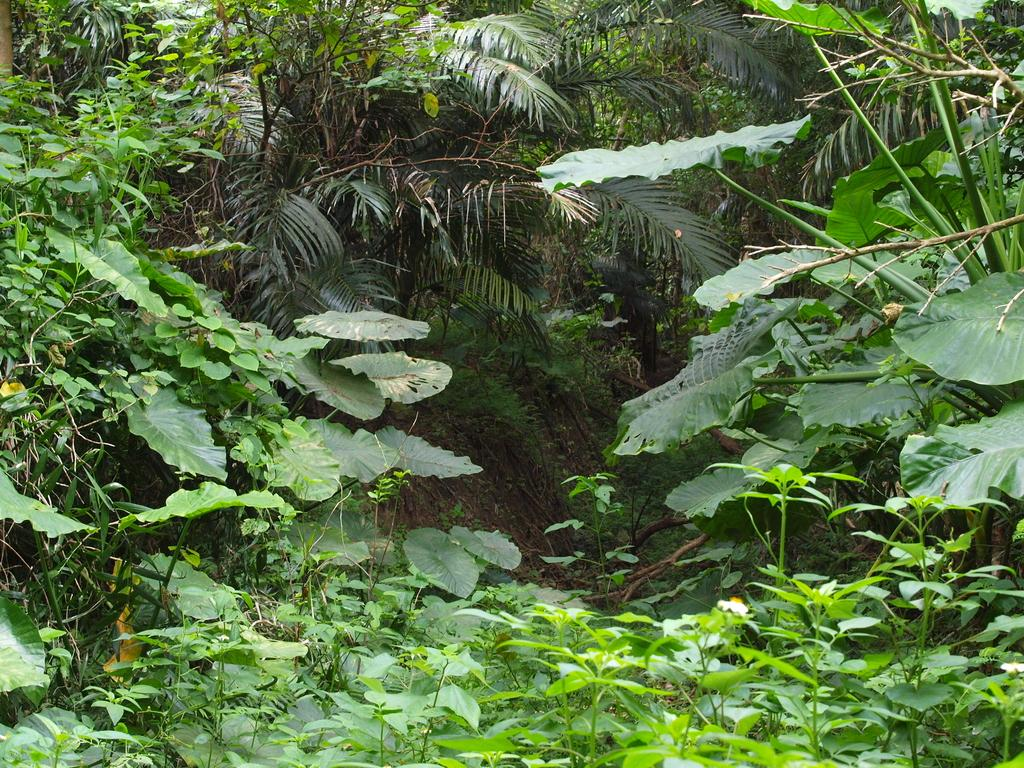What type of vegetation can be seen in the image? There is grass in the image. What else can be observed in the image besides grass? There are leaves of different shapes and sizes in the image. What type of bread can be seen in the image? There is no bread present in the image; it only features grass and leaves. What type of trade is depicted in the image? There is no trade depicted in the image; it only features natural elements like grass and leaves. 